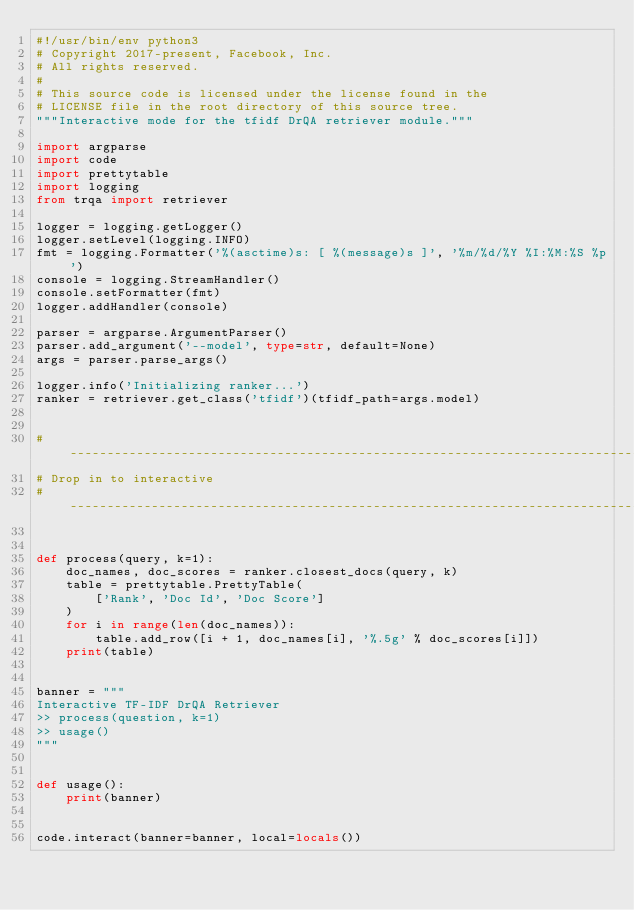Convert code to text. <code><loc_0><loc_0><loc_500><loc_500><_Python_>#!/usr/bin/env python3
# Copyright 2017-present, Facebook, Inc.
# All rights reserved.
#
# This source code is licensed under the license found in the
# LICENSE file in the root directory of this source tree.
"""Interactive mode for the tfidf DrQA retriever module."""

import argparse
import code
import prettytable
import logging
from trqa import retriever

logger = logging.getLogger()
logger.setLevel(logging.INFO)
fmt = logging.Formatter('%(asctime)s: [ %(message)s ]', '%m/%d/%Y %I:%M:%S %p')
console = logging.StreamHandler()
console.setFormatter(fmt)
logger.addHandler(console)

parser = argparse.ArgumentParser()
parser.add_argument('--model', type=str, default=None)
args = parser.parse_args()

logger.info('Initializing ranker...')
ranker = retriever.get_class('tfidf')(tfidf_path=args.model)


# ------------------------------------------------------------------------------
# Drop in to interactive
# ------------------------------------------------------------------------------


def process(query, k=1):
    doc_names, doc_scores = ranker.closest_docs(query, k)
    table = prettytable.PrettyTable(
        ['Rank', 'Doc Id', 'Doc Score']
    )
    for i in range(len(doc_names)):
        table.add_row([i + 1, doc_names[i], '%.5g' % doc_scores[i]])
    print(table)


banner = """
Interactive TF-IDF DrQA Retriever
>> process(question, k=1)
>> usage()
"""


def usage():
    print(banner)


code.interact(banner=banner, local=locals())
</code> 